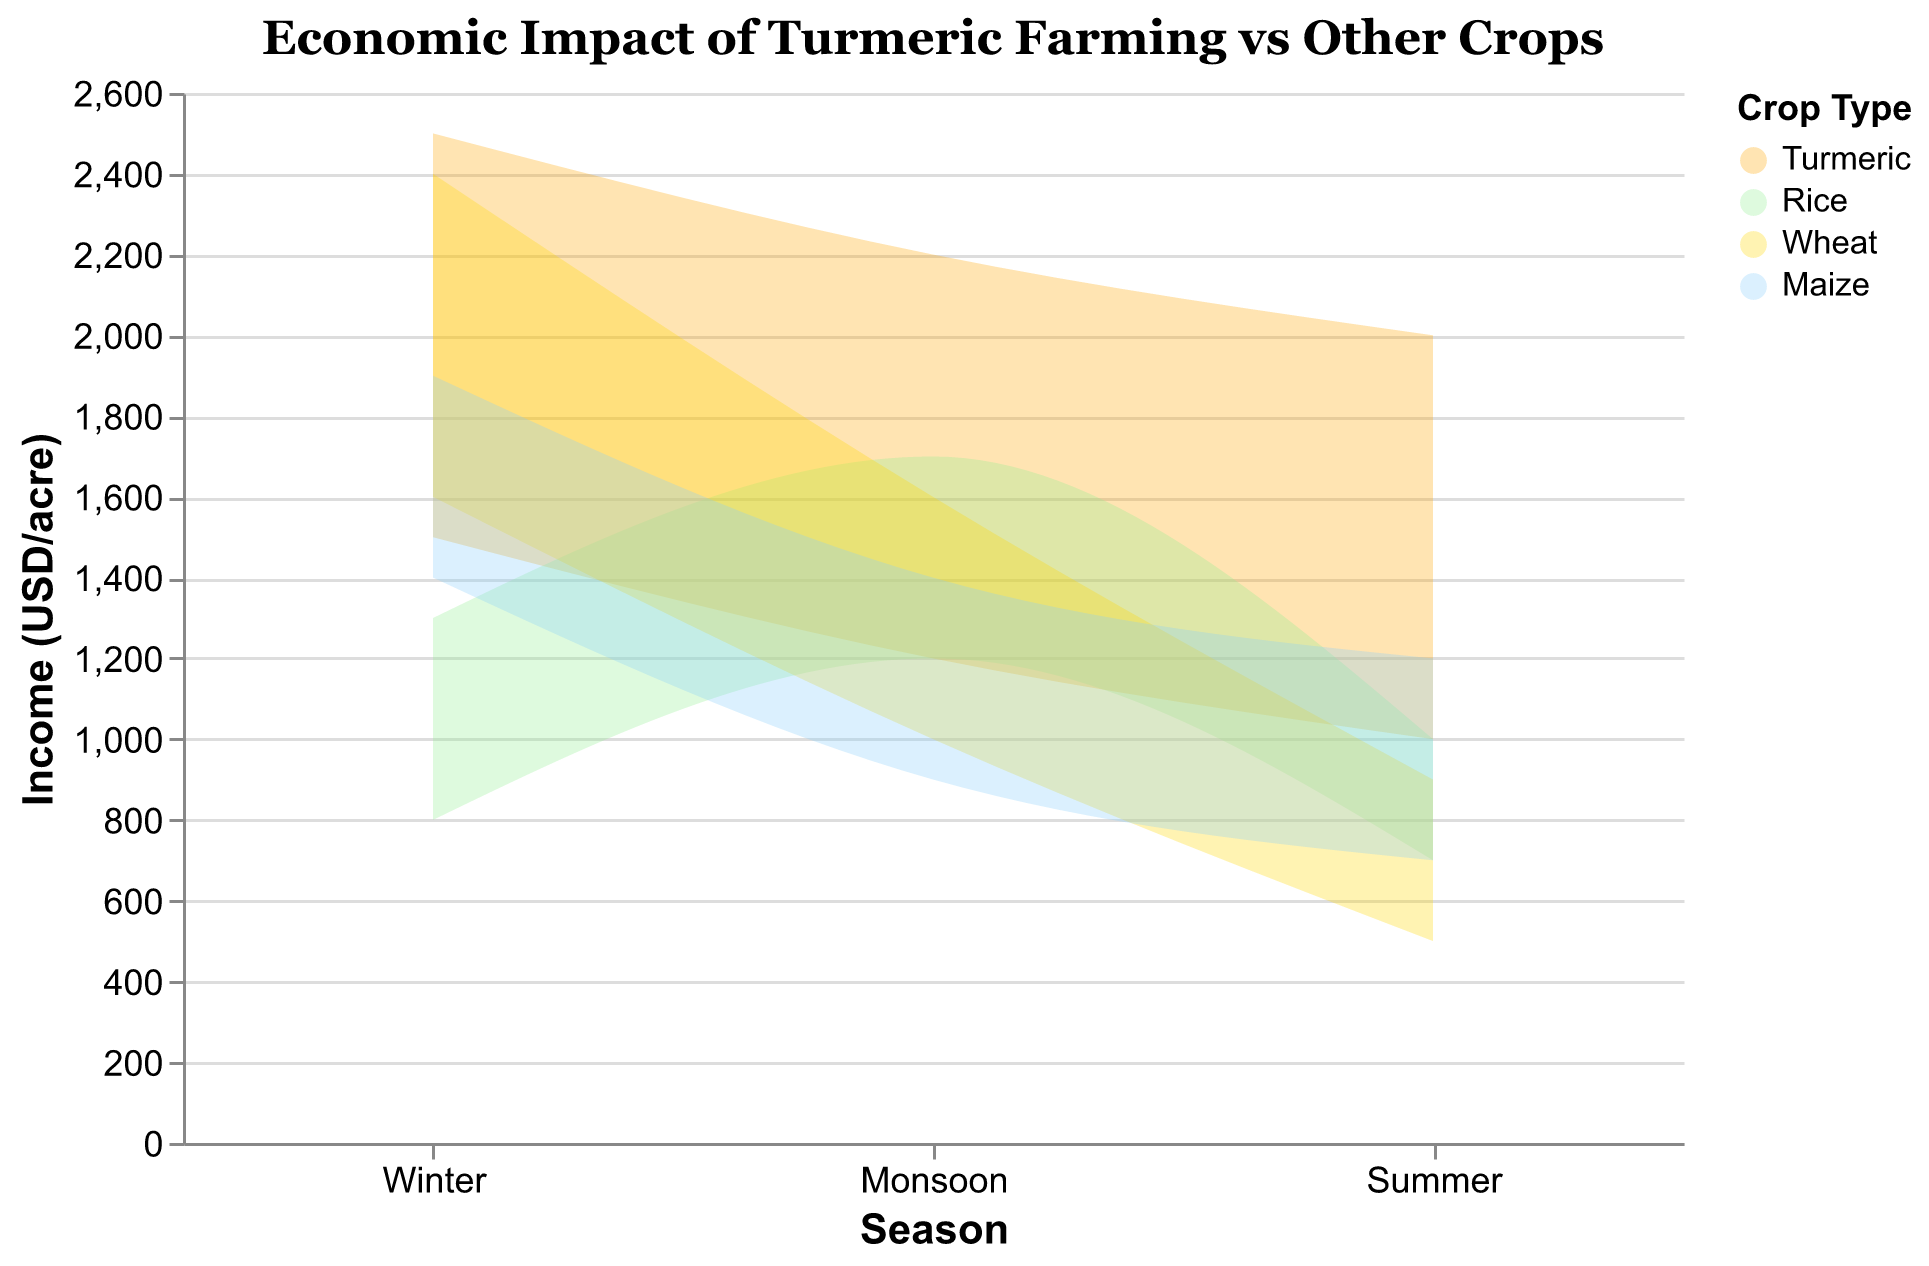What is the maximum income for turmeric in the winter season? The figure shows a range of incomes for each crop in different seasons, with the maximum income for each plot marked on the vertical scale. According to the chart, the maximum income for turmeric in winter is $2500 per acre.
Answer: $2500 per acre Which crop has the highest minimum income in the summer season? To determine this, examine the minimum income values for all crops in the 'Summer' section. Wheat has a minimum income of $500, Turmeric $1000, Rice $700, and Maize $700. Therefore, Turmeric has the highest minimum income in the summer.
Answer: Turmeric How does the income range of turmeric compare between the monsoon and winter seasons? The range for turmeric in winter is $1500 to $2500, and in the monsoon, it's $1200 to $2200. Both the minimum and maximum incomes are higher in winter compared to the monsoon season.
Answer: Higher in winter Which season has the least variation in income for maize? Variation in income is the difference between the maximum and minimum incomes. For maize, the range in winter is $500 (1400 to 1900), in the monsoon $500 (900 to 1400), and in the summer $500 (700 to 1200). Since all seasons have the same variation of $500, any season can be correct.
Answer: Any season What is the mean of the minimum incomes for turmeric across all seasons? The minimum incomes for turmeric are $1500 in winter, $1200 in monsoon, and $1000 in summer. The mean is calculated as (1500 + 1200 + 1000) / 3 = 3700 / 3 = $1233.33 per acre.
Answer: $1233.33 per acre Which crop has the highest maximum income across all seasons? Reviewing the chart for the peaks of all plotted areas, wheat has the maximum value of $2400 in winter, which is the highest among all crops across all seasons.
Answer: Wheat What is the difference in maximum income between rice and turmeric in the monsoon season? According to the chart, the maximum income for rice in the monsoon season is $1700 per acre, and for turmeric, it is $2200 per acre. The difference is 2200 - 1700 = $500.
Answer: $500 Which crop has the lowest maximum income in the summer? Reviewing the chart's maximum values for each crop in the summer, Wheat has the lowest maximum income of $900 per acre.
Answer: Wheat How does the range of incomes for rice in the monsoon compare to maize in the monsoon? For rice, the range in the monsoon is $500 (1200 to 1700). For maize, it is also $500 (900 to 1400). Therefore, the income range for both rice and maize is the same in the monsoon season.
Answer: Same 